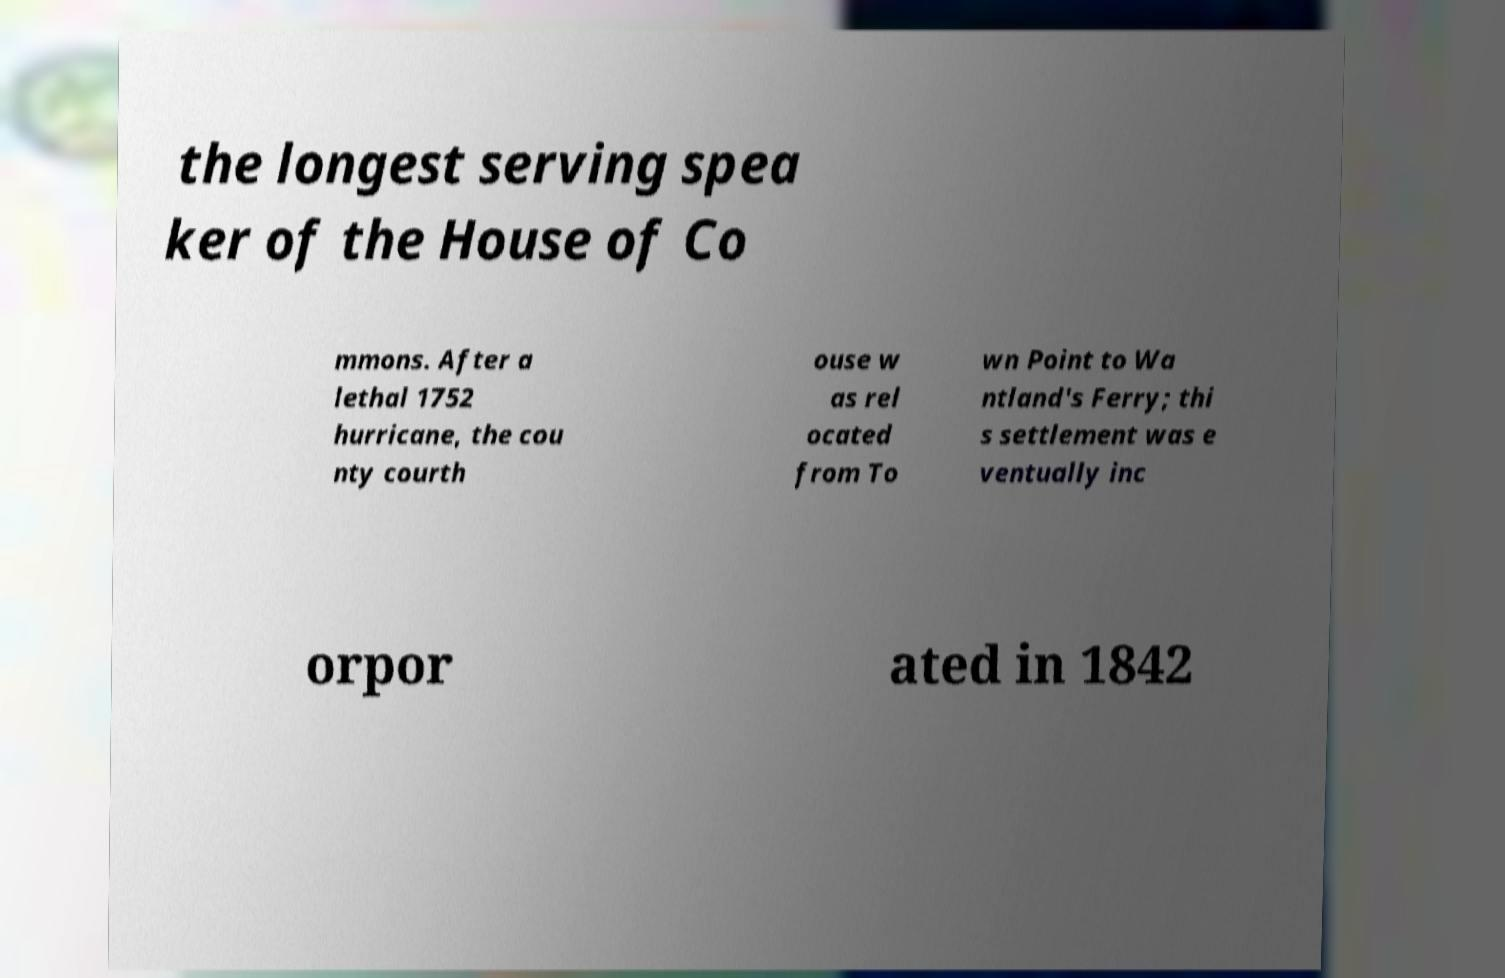Can you read and provide the text displayed in the image?This photo seems to have some interesting text. Can you extract and type it out for me? the longest serving spea ker of the House of Co mmons. After a lethal 1752 hurricane, the cou nty courth ouse w as rel ocated from To wn Point to Wa ntland's Ferry; thi s settlement was e ventually inc orpor ated in 1842 